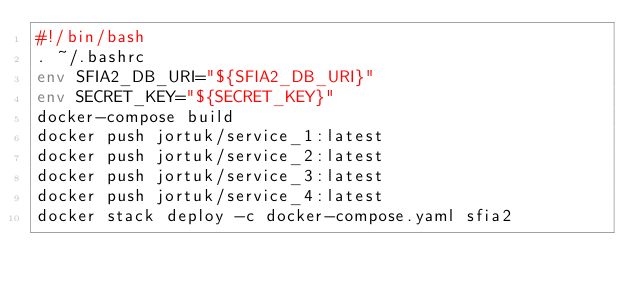Convert code to text. <code><loc_0><loc_0><loc_500><loc_500><_Bash_>#!/bin/bash
. ~/.bashrc
env SFIA2_DB_URI="${SFIA2_DB_URI}" 
env SECRET_KEY="${SECRET_KEY}"
docker-compose build
docker push jortuk/service_1:latest
docker push jortuk/service_2:latest
docker push jortuk/service_3:latest
docker push jortuk/service_4:latest
docker stack deploy -c docker-compose.yaml sfia2</code> 